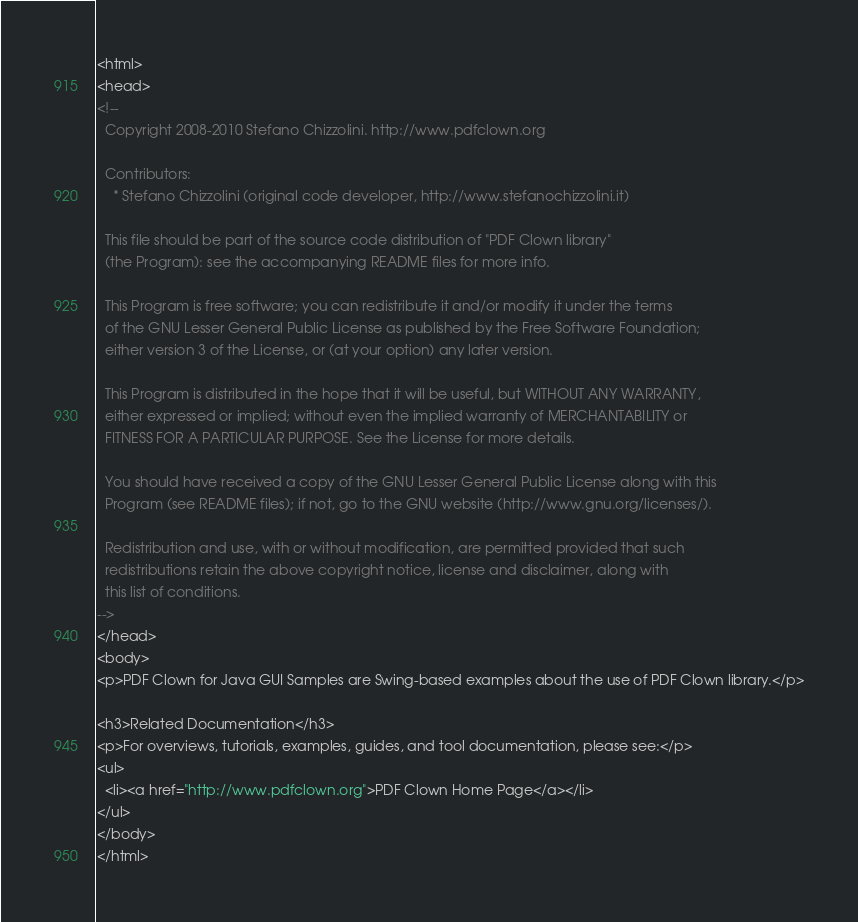<code> <loc_0><loc_0><loc_500><loc_500><_HTML_><html>
<head>
<!--
  Copyright 2008-2010 Stefano Chizzolini. http://www.pdfclown.org

  Contributors:
    * Stefano Chizzolini (original code developer, http://www.stefanochizzolini.it)

  This file should be part of the source code distribution of "PDF Clown library"
  (the Program): see the accompanying README files for more info.

  This Program is free software; you can redistribute it and/or modify it under the terms
  of the GNU Lesser General Public License as published by the Free Software Foundation;
  either version 3 of the License, or (at your option) any later version.

  This Program is distributed in the hope that it will be useful, but WITHOUT ANY WARRANTY,
  either expressed or implied; without even the implied warranty of MERCHANTABILITY or
  FITNESS FOR A PARTICULAR PURPOSE. See the License for more details.

  You should have received a copy of the GNU Lesser General Public License along with this
  Program (see README files); if not, go to the GNU website (http://www.gnu.org/licenses/).

  Redistribution and use, with or without modification, are permitted provided that such
  redistributions retain the above copyright notice, license and disclaimer, along with
  this list of conditions.
-->
</head>
<body>
<p>PDF Clown for Java GUI Samples are Swing-based examples about the use of PDF Clown library.</p>

<h3>Related Documentation</h3>
<p>For overviews, tutorials, examples, guides, and tool documentation, please see:</p>
<ul>
  <li><a href="http://www.pdfclown.org">PDF Clown Home Page</a></li>
</ul>
</body>
</html>
</code> 